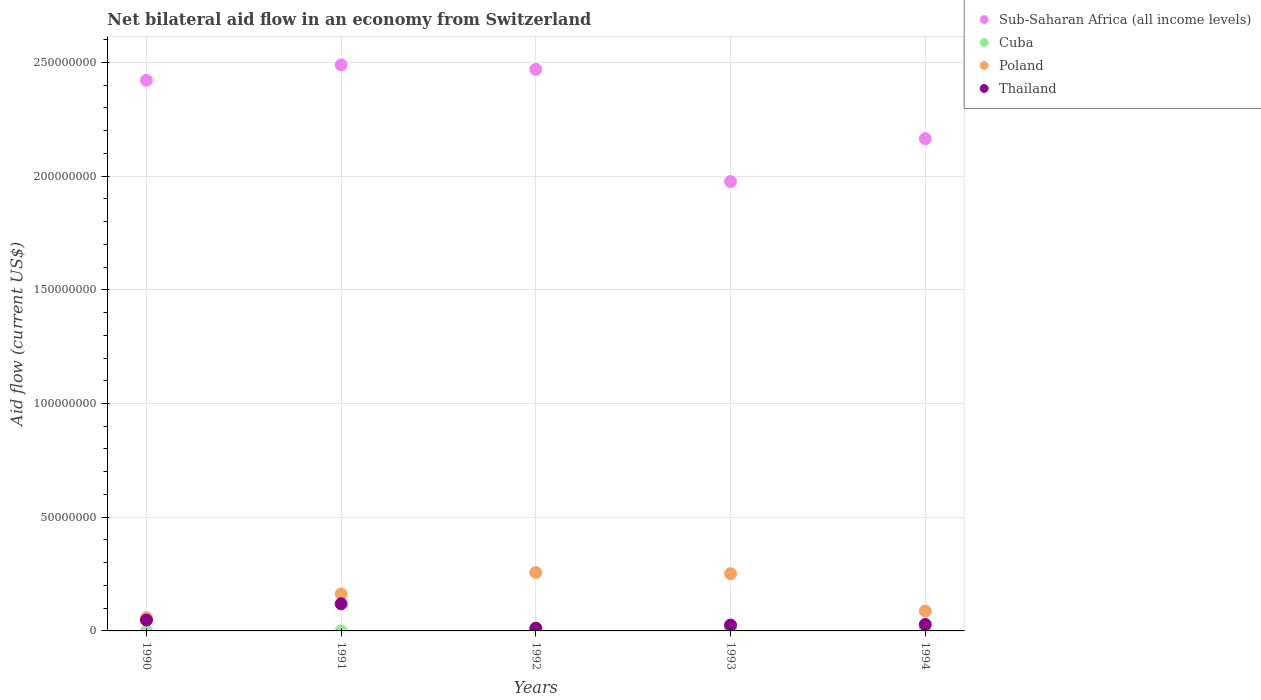How many different coloured dotlines are there?
Make the answer very short. 4. Is the number of dotlines equal to the number of legend labels?
Your response must be concise. Yes. What is the net bilateral aid flow in Thailand in 1990?
Ensure brevity in your answer.  4.78e+06. Across all years, what is the maximum net bilateral aid flow in Sub-Saharan Africa (all income levels)?
Your answer should be very brief. 2.49e+08. Across all years, what is the minimum net bilateral aid flow in Sub-Saharan Africa (all income levels)?
Ensure brevity in your answer.  1.98e+08. In which year was the net bilateral aid flow in Sub-Saharan Africa (all income levels) maximum?
Offer a very short reply. 1991. In which year was the net bilateral aid flow in Sub-Saharan Africa (all income levels) minimum?
Provide a short and direct response. 1993. What is the total net bilateral aid flow in Cuba in the graph?
Offer a very short reply. 9.30e+05. What is the difference between the net bilateral aid flow in Cuba in 1992 and that in 1993?
Keep it short and to the point. -4.50e+05. What is the difference between the net bilateral aid flow in Poland in 1991 and the net bilateral aid flow in Sub-Saharan Africa (all income levels) in 1994?
Provide a succinct answer. -2.00e+08. What is the average net bilateral aid flow in Poland per year?
Give a very brief answer. 1.63e+07. In the year 1991, what is the difference between the net bilateral aid flow in Sub-Saharan Africa (all income levels) and net bilateral aid flow in Poland?
Offer a very short reply. 2.33e+08. What is the ratio of the net bilateral aid flow in Cuba in 1991 to that in 1994?
Provide a succinct answer. 0.21. Is the difference between the net bilateral aid flow in Sub-Saharan Africa (all income levels) in 1993 and 1994 greater than the difference between the net bilateral aid flow in Poland in 1993 and 1994?
Offer a terse response. No. What is the difference between the highest and the second highest net bilateral aid flow in Thailand?
Provide a short and direct response. 7.16e+06. What is the difference between the highest and the lowest net bilateral aid flow in Poland?
Your answer should be very brief. 1.99e+07. In how many years, is the net bilateral aid flow in Poland greater than the average net bilateral aid flow in Poland taken over all years?
Give a very brief answer. 2. Is it the case that in every year, the sum of the net bilateral aid flow in Poland and net bilateral aid flow in Sub-Saharan Africa (all income levels)  is greater than the sum of net bilateral aid flow in Thailand and net bilateral aid flow in Cuba?
Offer a very short reply. Yes. What is the difference between two consecutive major ticks on the Y-axis?
Offer a terse response. 5.00e+07. Are the values on the major ticks of Y-axis written in scientific E-notation?
Provide a succinct answer. No. Does the graph contain any zero values?
Make the answer very short. No. How many legend labels are there?
Offer a terse response. 4. What is the title of the graph?
Ensure brevity in your answer.  Net bilateral aid flow in an economy from Switzerland. Does "Libya" appear as one of the legend labels in the graph?
Ensure brevity in your answer.  No. What is the Aid flow (current US$) in Sub-Saharan Africa (all income levels) in 1990?
Keep it short and to the point. 2.42e+08. What is the Aid flow (current US$) of Cuba in 1990?
Ensure brevity in your answer.  3.00e+04. What is the Aid flow (current US$) in Poland in 1990?
Offer a very short reply. 5.79e+06. What is the Aid flow (current US$) of Thailand in 1990?
Offer a very short reply. 4.78e+06. What is the Aid flow (current US$) of Sub-Saharan Africa (all income levels) in 1991?
Keep it short and to the point. 2.49e+08. What is the Aid flow (current US$) of Cuba in 1991?
Your answer should be very brief. 4.00e+04. What is the Aid flow (current US$) in Poland in 1991?
Your answer should be very brief. 1.63e+07. What is the Aid flow (current US$) of Thailand in 1991?
Give a very brief answer. 1.19e+07. What is the Aid flow (current US$) in Sub-Saharan Africa (all income levels) in 1992?
Offer a terse response. 2.47e+08. What is the Aid flow (current US$) in Poland in 1992?
Keep it short and to the point. 2.57e+07. What is the Aid flow (current US$) of Thailand in 1992?
Give a very brief answer. 1.21e+06. What is the Aid flow (current US$) of Sub-Saharan Africa (all income levels) in 1993?
Your answer should be very brief. 1.98e+08. What is the Aid flow (current US$) of Cuba in 1993?
Ensure brevity in your answer.  5.60e+05. What is the Aid flow (current US$) of Poland in 1993?
Offer a terse response. 2.52e+07. What is the Aid flow (current US$) in Thailand in 1993?
Offer a very short reply. 2.58e+06. What is the Aid flow (current US$) of Sub-Saharan Africa (all income levels) in 1994?
Provide a short and direct response. 2.16e+08. What is the Aid flow (current US$) in Cuba in 1994?
Offer a terse response. 1.90e+05. What is the Aid flow (current US$) in Poland in 1994?
Offer a very short reply. 8.76e+06. What is the Aid flow (current US$) in Thailand in 1994?
Your answer should be compact. 2.84e+06. Across all years, what is the maximum Aid flow (current US$) of Sub-Saharan Africa (all income levels)?
Give a very brief answer. 2.49e+08. Across all years, what is the maximum Aid flow (current US$) of Cuba?
Your response must be concise. 5.60e+05. Across all years, what is the maximum Aid flow (current US$) of Poland?
Your answer should be compact. 2.57e+07. Across all years, what is the maximum Aid flow (current US$) in Thailand?
Keep it short and to the point. 1.19e+07. Across all years, what is the minimum Aid flow (current US$) in Sub-Saharan Africa (all income levels)?
Your response must be concise. 1.98e+08. Across all years, what is the minimum Aid flow (current US$) in Cuba?
Provide a succinct answer. 3.00e+04. Across all years, what is the minimum Aid flow (current US$) in Poland?
Offer a very short reply. 5.79e+06. Across all years, what is the minimum Aid flow (current US$) of Thailand?
Give a very brief answer. 1.21e+06. What is the total Aid flow (current US$) of Sub-Saharan Africa (all income levels) in the graph?
Keep it short and to the point. 1.15e+09. What is the total Aid flow (current US$) in Cuba in the graph?
Keep it short and to the point. 9.30e+05. What is the total Aid flow (current US$) of Poland in the graph?
Provide a short and direct response. 8.17e+07. What is the total Aid flow (current US$) in Thailand in the graph?
Offer a terse response. 2.34e+07. What is the difference between the Aid flow (current US$) of Sub-Saharan Africa (all income levels) in 1990 and that in 1991?
Make the answer very short. -6.79e+06. What is the difference between the Aid flow (current US$) of Poland in 1990 and that in 1991?
Your answer should be very brief. -1.05e+07. What is the difference between the Aid flow (current US$) in Thailand in 1990 and that in 1991?
Your answer should be compact. -7.16e+06. What is the difference between the Aid flow (current US$) in Sub-Saharan Africa (all income levels) in 1990 and that in 1992?
Give a very brief answer. -4.80e+06. What is the difference between the Aid flow (current US$) of Cuba in 1990 and that in 1992?
Offer a very short reply. -8.00e+04. What is the difference between the Aid flow (current US$) of Poland in 1990 and that in 1992?
Offer a terse response. -1.99e+07. What is the difference between the Aid flow (current US$) of Thailand in 1990 and that in 1992?
Make the answer very short. 3.57e+06. What is the difference between the Aid flow (current US$) in Sub-Saharan Africa (all income levels) in 1990 and that in 1993?
Your response must be concise. 4.45e+07. What is the difference between the Aid flow (current US$) in Cuba in 1990 and that in 1993?
Provide a short and direct response. -5.30e+05. What is the difference between the Aid flow (current US$) in Poland in 1990 and that in 1993?
Make the answer very short. -1.94e+07. What is the difference between the Aid flow (current US$) in Thailand in 1990 and that in 1993?
Your response must be concise. 2.20e+06. What is the difference between the Aid flow (current US$) of Sub-Saharan Africa (all income levels) in 1990 and that in 1994?
Make the answer very short. 2.56e+07. What is the difference between the Aid flow (current US$) of Poland in 1990 and that in 1994?
Your answer should be very brief. -2.97e+06. What is the difference between the Aid flow (current US$) in Thailand in 1990 and that in 1994?
Give a very brief answer. 1.94e+06. What is the difference between the Aid flow (current US$) of Sub-Saharan Africa (all income levels) in 1991 and that in 1992?
Your answer should be compact. 1.99e+06. What is the difference between the Aid flow (current US$) of Cuba in 1991 and that in 1992?
Give a very brief answer. -7.00e+04. What is the difference between the Aid flow (current US$) of Poland in 1991 and that in 1992?
Ensure brevity in your answer.  -9.42e+06. What is the difference between the Aid flow (current US$) in Thailand in 1991 and that in 1992?
Keep it short and to the point. 1.07e+07. What is the difference between the Aid flow (current US$) in Sub-Saharan Africa (all income levels) in 1991 and that in 1993?
Give a very brief answer. 5.13e+07. What is the difference between the Aid flow (current US$) in Cuba in 1991 and that in 1993?
Your response must be concise. -5.20e+05. What is the difference between the Aid flow (current US$) of Poland in 1991 and that in 1993?
Make the answer very short. -8.91e+06. What is the difference between the Aid flow (current US$) of Thailand in 1991 and that in 1993?
Provide a succinct answer. 9.36e+06. What is the difference between the Aid flow (current US$) in Sub-Saharan Africa (all income levels) in 1991 and that in 1994?
Give a very brief answer. 3.24e+07. What is the difference between the Aid flow (current US$) in Poland in 1991 and that in 1994?
Give a very brief answer. 7.50e+06. What is the difference between the Aid flow (current US$) in Thailand in 1991 and that in 1994?
Ensure brevity in your answer.  9.10e+06. What is the difference between the Aid flow (current US$) in Sub-Saharan Africa (all income levels) in 1992 and that in 1993?
Your answer should be compact. 4.93e+07. What is the difference between the Aid flow (current US$) of Cuba in 1992 and that in 1993?
Offer a terse response. -4.50e+05. What is the difference between the Aid flow (current US$) in Poland in 1992 and that in 1993?
Your answer should be very brief. 5.10e+05. What is the difference between the Aid flow (current US$) in Thailand in 1992 and that in 1993?
Offer a terse response. -1.37e+06. What is the difference between the Aid flow (current US$) in Sub-Saharan Africa (all income levels) in 1992 and that in 1994?
Offer a terse response. 3.04e+07. What is the difference between the Aid flow (current US$) in Poland in 1992 and that in 1994?
Make the answer very short. 1.69e+07. What is the difference between the Aid flow (current US$) of Thailand in 1992 and that in 1994?
Offer a very short reply. -1.63e+06. What is the difference between the Aid flow (current US$) of Sub-Saharan Africa (all income levels) in 1993 and that in 1994?
Your answer should be very brief. -1.89e+07. What is the difference between the Aid flow (current US$) of Poland in 1993 and that in 1994?
Your answer should be compact. 1.64e+07. What is the difference between the Aid flow (current US$) in Sub-Saharan Africa (all income levels) in 1990 and the Aid flow (current US$) in Cuba in 1991?
Your response must be concise. 2.42e+08. What is the difference between the Aid flow (current US$) of Sub-Saharan Africa (all income levels) in 1990 and the Aid flow (current US$) of Poland in 1991?
Offer a terse response. 2.26e+08. What is the difference between the Aid flow (current US$) in Sub-Saharan Africa (all income levels) in 1990 and the Aid flow (current US$) in Thailand in 1991?
Provide a short and direct response. 2.30e+08. What is the difference between the Aid flow (current US$) of Cuba in 1990 and the Aid flow (current US$) of Poland in 1991?
Offer a terse response. -1.62e+07. What is the difference between the Aid flow (current US$) in Cuba in 1990 and the Aid flow (current US$) in Thailand in 1991?
Offer a very short reply. -1.19e+07. What is the difference between the Aid flow (current US$) of Poland in 1990 and the Aid flow (current US$) of Thailand in 1991?
Provide a succinct answer. -6.15e+06. What is the difference between the Aid flow (current US$) in Sub-Saharan Africa (all income levels) in 1990 and the Aid flow (current US$) in Cuba in 1992?
Your response must be concise. 2.42e+08. What is the difference between the Aid flow (current US$) in Sub-Saharan Africa (all income levels) in 1990 and the Aid flow (current US$) in Poland in 1992?
Your answer should be very brief. 2.16e+08. What is the difference between the Aid flow (current US$) of Sub-Saharan Africa (all income levels) in 1990 and the Aid flow (current US$) of Thailand in 1992?
Provide a short and direct response. 2.41e+08. What is the difference between the Aid flow (current US$) in Cuba in 1990 and the Aid flow (current US$) in Poland in 1992?
Make the answer very short. -2.56e+07. What is the difference between the Aid flow (current US$) in Cuba in 1990 and the Aid flow (current US$) in Thailand in 1992?
Your answer should be very brief. -1.18e+06. What is the difference between the Aid flow (current US$) in Poland in 1990 and the Aid flow (current US$) in Thailand in 1992?
Keep it short and to the point. 4.58e+06. What is the difference between the Aid flow (current US$) of Sub-Saharan Africa (all income levels) in 1990 and the Aid flow (current US$) of Cuba in 1993?
Give a very brief answer. 2.42e+08. What is the difference between the Aid flow (current US$) of Sub-Saharan Africa (all income levels) in 1990 and the Aid flow (current US$) of Poland in 1993?
Keep it short and to the point. 2.17e+08. What is the difference between the Aid flow (current US$) in Sub-Saharan Africa (all income levels) in 1990 and the Aid flow (current US$) in Thailand in 1993?
Provide a succinct answer. 2.40e+08. What is the difference between the Aid flow (current US$) in Cuba in 1990 and the Aid flow (current US$) in Poland in 1993?
Keep it short and to the point. -2.51e+07. What is the difference between the Aid flow (current US$) of Cuba in 1990 and the Aid flow (current US$) of Thailand in 1993?
Offer a terse response. -2.55e+06. What is the difference between the Aid flow (current US$) of Poland in 1990 and the Aid flow (current US$) of Thailand in 1993?
Offer a terse response. 3.21e+06. What is the difference between the Aid flow (current US$) in Sub-Saharan Africa (all income levels) in 1990 and the Aid flow (current US$) in Cuba in 1994?
Make the answer very short. 2.42e+08. What is the difference between the Aid flow (current US$) in Sub-Saharan Africa (all income levels) in 1990 and the Aid flow (current US$) in Poland in 1994?
Give a very brief answer. 2.33e+08. What is the difference between the Aid flow (current US$) of Sub-Saharan Africa (all income levels) in 1990 and the Aid flow (current US$) of Thailand in 1994?
Offer a very short reply. 2.39e+08. What is the difference between the Aid flow (current US$) in Cuba in 1990 and the Aid flow (current US$) in Poland in 1994?
Offer a terse response. -8.73e+06. What is the difference between the Aid flow (current US$) in Cuba in 1990 and the Aid flow (current US$) in Thailand in 1994?
Give a very brief answer. -2.81e+06. What is the difference between the Aid flow (current US$) in Poland in 1990 and the Aid flow (current US$) in Thailand in 1994?
Your answer should be compact. 2.95e+06. What is the difference between the Aid flow (current US$) of Sub-Saharan Africa (all income levels) in 1991 and the Aid flow (current US$) of Cuba in 1992?
Make the answer very short. 2.49e+08. What is the difference between the Aid flow (current US$) in Sub-Saharan Africa (all income levels) in 1991 and the Aid flow (current US$) in Poland in 1992?
Make the answer very short. 2.23e+08. What is the difference between the Aid flow (current US$) in Sub-Saharan Africa (all income levels) in 1991 and the Aid flow (current US$) in Thailand in 1992?
Your answer should be very brief. 2.48e+08. What is the difference between the Aid flow (current US$) in Cuba in 1991 and the Aid flow (current US$) in Poland in 1992?
Your answer should be compact. -2.56e+07. What is the difference between the Aid flow (current US$) of Cuba in 1991 and the Aid flow (current US$) of Thailand in 1992?
Provide a succinct answer. -1.17e+06. What is the difference between the Aid flow (current US$) of Poland in 1991 and the Aid flow (current US$) of Thailand in 1992?
Your answer should be compact. 1.50e+07. What is the difference between the Aid flow (current US$) in Sub-Saharan Africa (all income levels) in 1991 and the Aid flow (current US$) in Cuba in 1993?
Offer a terse response. 2.48e+08. What is the difference between the Aid flow (current US$) in Sub-Saharan Africa (all income levels) in 1991 and the Aid flow (current US$) in Poland in 1993?
Give a very brief answer. 2.24e+08. What is the difference between the Aid flow (current US$) in Sub-Saharan Africa (all income levels) in 1991 and the Aid flow (current US$) in Thailand in 1993?
Give a very brief answer. 2.46e+08. What is the difference between the Aid flow (current US$) in Cuba in 1991 and the Aid flow (current US$) in Poland in 1993?
Make the answer very short. -2.51e+07. What is the difference between the Aid flow (current US$) in Cuba in 1991 and the Aid flow (current US$) in Thailand in 1993?
Offer a terse response. -2.54e+06. What is the difference between the Aid flow (current US$) in Poland in 1991 and the Aid flow (current US$) in Thailand in 1993?
Keep it short and to the point. 1.37e+07. What is the difference between the Aid flow (current US$) of Sub-Saharan Africa (all income levels) in 1991 and the Aid flow (current US$) of Cuba in 1994?
Your answer should be compact. 2.49e+08. What is the difference between the Aid flow (current US$) of Sub-Saharan Africa (all income levels) in 1991 and the Aid flow (current US$) of Poland in 1994?
Offer a terse response. 2.40e+08. What is the difference between the Aid flow (current US$) in Sub-Saharan Africa (all income levels) in 1991 and the Aid flow (current US$) in Thailand in 1994?
Keep it short and to the point. 2.46e+08. What is the difference between the Aid flow (current US$) in Cuba in 1991 and the Aid flow (current US$) in Poland in 1994?
Provide a short and direct response. -8.72e+06. What is the difference between the Aid flow (current US$) in Cuba in 1991 and the Aid flow (current US$) in Thailand in 1994?
Offer a terse response. -2.80e+06. What is the difference between the Aid flow (current US$) of Poland in 1991 and the Aid flow (current US$) of Thailand in 1994?
Your answer should be compact. 1.34e+07. What is the difference between the Aid flow (current US$) in Sub-Saharan Africa (all income levels) in 1992 and the Aid flow (current US$) in Cuba in 1993?
Offer a very short reply. 2.46e+08. What is the difference between the Aid flow (current US$) in Sub-Saharan Africa (all income levels) in 1992 and the Aid flow (current US$) in Poland in 1993?
Make the answer very short. 2.22e+08. What is the difference between the Aid flow (current US$) in Sub-Saharan Africa (all income levels) in 1992 and the Aid flow (current US$) in Thailand in 1993?
Provide a succinct answer. 2.44e+08. What is the difference between the Aid flow (current US$) of Cuba in 1992 and the Aid flow (current US$) of Poland in 1993?
Keep it short and to the point. -2.51e+07. What is the difference between the Aid flow (current US$) in Cuba in 1992 and the Aid flow (current US$) in Thailand in 1993?
Your answer should be compact. -2.47e+06. What is the difference between the Aid flow (current US$) of Poland in 1992 and the Aid flow (current US$) of Thailand in 1993?
Provide a short and direct response. 2.31e+07. What is the difference between the Aid flow (current US$) of Sub-Saharan Africa (all income levels) in 1992 and the Aid flow (current US$) of Cuba in 1994?
Your response must be concise. 2.47e+08. What is the difference between the Aid flow (current US$) in Sub-Saharan Africa (all income levels) in 1992 and the Aid flow (current US$) in Poland in 1994?
Offer a very short reply. 2.38e+08. What is the difference between the Aid flow (current US$) in Sub-Saharan Africa (all income levels) in 1992 and the Aid flow (current US$) in Thailand in 1994?
Give a very brief answer. 2.44e+08. What is the difference between the Aid flow (current US$) of Cuba in 1992 and the Aid flow (current US$) of Poland in 1994?
Your response must be concise. -8.65e+06. What is the difference between the Aid flow (current US$) in Cuba in 1992 and the Aid flow (current US$) in Thailand in 1994?
Your answer should be very brief. -2.73e+06. What is the difference between the Aid flow (current US$) of Poland in 1992 and the Aid flow (current US$) of Thailand in 1994?
Your answer should be very brief. 2.28e+07. What is the difference between the Aid flow (current US$) of Sub-Saharan Africa (all income levels) in 1993 and the Aid flow (current US$) of Cuba in 1994?
Your response must be concise. 1.97e+08. What is the difference between the Aid flow (current US$) in Sub-Saharan Africa (all income levels) in 1993 and the Aid flow (current US$) in Poland in 1994?
Offer a very short reply. 1.89e+08. What is the difference between the Aid flow (current US$) in Sub-Saharan Africa (all income levels) in 1993 and the Aid flow (current US$) in Thailand in 1994?
Give a very brief answer. 1.95e+08. What is the difference between the Aid flow (current US$) of Cuba in 1993 and the Aid flow (current US$) of Poland in 1994?
Offer a terse response. -8.20e+06. What is the difference between the Aid flow (current US$) of Cuba in 1993 and the Aid flow (current US$) of Thailand in 1994?
Your answer should be compact. -2.28e+06. What is the difference between the Aid flow (current US$) of Poland in 1993 and the Aid flow (current US$) of Thailand in 1994?
Keep it short and to the point. 2.23e+07. What is the average Aid flow (current US$) in Sub-Saharan Africa (all income levels) per year?
Your answer should be compact. 2.30e+08. What is the average Aid flow (current US$) in Cuba per year?
Provide a short and direct response. 1.86e+05. What is the average Aid flow (current US$) of Poland per year?
Your response must be concise. 1.63e+07. What is the average Aid flow (current US$) in Thailand per year?
Make the answer very short. 4.67e+06. In the year 1990, what is the difference between the Aid flow (current US$) in Sub-Saharan Africa (all income levels) and Aid flow (current US$) in Cuba?
Provide a short and direct response. 2.42e+08. In the year 1990, what is the difference between the Aid flow (current US$) of Sub-Saharan Africa (all income levels) and Aid flow (current US$) of Poland?
Ensure brevity in your answer.  2.36e+08. In the year 1990, what is the difference between the Aid flow (current US$) in Sub-Saharan Africa (all income levels) and Aid flow (current US$) in Thailand?
Provide a short and direct response. 2.37e+08. In the year 1990, what is the difference between the Aid flow (current US$) in Cuba and Aid flow (current US$) in Poland?
Make the answer very short. -5.76e+06. In the year 1990, what is the difference between the Aid flow (current US$) of Cuba and Aid flow (current US$) of Thailand?
Provide a succinct answer. -4.75e+06. In the year 1990, what is the difference between the Aid flow (current US$) of Poland and Aid flow (current US$) of Thailand?
Your response must be concise. 1.01e+06. In the year 1991, what is the difference between the Aid flow (current US$) in Sub-Saharan Africa (all income levels) and Aid flow (current US$) in Cuba?
Your answer should be compact. 2.49e+08. In the year 1991, what is the difference between the Aid flow (current US$) in Sub-Saharan Africa (all income levels) and Aid flow (current US$) in Poland?
Your answer should be very brief. 2.33e+08. In the year 1991, what is the difference between the Aid flow (current US$) in Sub-Saharan Africa (all income levels) and Aid flow (current US$) in Thailand?
Offer a terse response. 2.37e+08. In the year 1991, what is the difference between the Aid flow (current US$) in Cuba and Aid flow (current US$) in Poland?
Offer a terse response. -1.62e+07. In the year 1991, what is the difference between the Aid flow (current US$) in Cuba and Aid flow (current US$) in Thailand?
Your answer should be very brief. -1.19e+07. In the year 1991, what is the difference between the Aid flow (current US$) of Poland and Aid flow (current US$) of Thailand?
Offer a terse response. 4.32e+06. In the year 1992, what is the difference between the Aid flow (current US$) in Sub-Saharan Africa (all income levels) and Aid flow (current US$) in Cuba?
Your answer should be very brief. 2.47e+08. In the year 1992, what is the difference between the Aid flow (current US$) of Sub-Saharan Africa (all income levels) and Aid flow (current US$) of Poland?
Your answer should be compact. 2.21e+08. In the year 1992, what is the difference between the Aid flow (current US$) of Sub-Saharan Africa (all income levels) and Aid flow (current US$) of Thailand?
Give a very brief answer. 2.46e+08. In the year 1992, what is the difference between the Aid flow (current US$) of Cuba and Aid flow (current US$) of Poland?
Provide a short and direct response. -2.56e+07. In the year 1992, what is the difference between the Aid flow (current US$) of Cuba and Aid flow (current US$) of Thailand?
Give a very brief answer. -1.10e+06. In the year 1992, what is the difference between the Aid flow (current US$) of Poland and Aid flow (current US$) of Thailand?
Offer a terse response. 2.45e+07. In the year 1993, what is the difference between the Aid flow (current US$) of Sub-Saharan Africa (all income levels) and Aid flow (current US$) of Cuba?
Give a very brief answer. 1.97e+08. In the year 1993, what is the difference between the Aid flow (current US$) in Sub-Saharan Africa (all income levels) and Aid flow (current US$) in Poland?
Make the answer very short. 1.72e+08. In the year 1993, what is the difference between the Aid flow (current US$) in Sub-Saharan Africa (all income levels) and Aid flow (current US$) in Thailand?
Ensure brevity in your answer.  1.95e+08. In the year 1993, what is the difference between the Aid flow (current US$) of Cuba and Aid flow (current US$) of Poland?
Ensure brevity in your answer.  -2.46e+07. In the year 1993, what is the difference between the Aid flow (current US$) in Cuba and Aid flow (current US$) in Thailand?
Offer a very short reply. -2.02e+06. In the year 1993, what is the difference between the Aid flow (current US$) in Poland and Aid flow (current US$) in Thailand?
Provide a succinct answer. 2.26e+07. In the year 1994, what is the difference between the Aid flow (current US$) of Sub-Saharan Africa (all income levels) and Aid flow (current US$) of Cuba?
Keep it short and to the point. 2.16e+08. In the year 1994, what is the difference between the Aid flow (current US$) of Sub-Saharan Africa (all income levels) and Aid flow (current US$) of Poland?
Offer a very short reply. 2.08e+08. In the year 1994, what is the difference between the Aid flow (current US$) in Sub-Saharan Africa (all income levels) and Aid flow (current US$) in Thailand?
Your response must be concise. 2.14e+08. In the year 1994, what is the difference between the Aid flow (current US$) of Cuba and Aid flow (current US$) of Poland?
Provide a succinct answer. -8.57e+06. In the year 1994, what is the difference between the Aid flow (current US$) in Cuba and Aid flow (current US$) in Thailand?
Keep it short and to the point. -2.65e+06. In the year 1994, what is the difference between the Aid flow (current US$) in Poland and Aid flow (current US$) in Thailand?
Keep it short and to the point. 5.92e+06. What is the ratio of the Aid flow (current US$) of Sub-Saharan Africa (all income levels) in 1990 to that in 1991?
Provide a succinct answer. 0.97. What is the ratio of the Aid flow (current US$) in Cuba in 1990 to that in 1991?
Ensure brevity in your answer.  0.75. What is the ratio of the Aid flow (current US$) of Poland in 1990 to that in 1991?
Give a very brief answer. 0.36. What is the ratio of the Aid flow (current US$) in Thailand in 1990 to that in 1991?
Provide a short and direct response. 0.4. What is the ratio of the Aid flow (current US$) in Sub-Saharan Africa (all income levels) in 1990 to that in 1992?
Make the answer very short. 0.98. What is the ratio of the Aid flow (current US$) in Cuba in 1990 to that in 1992?
Provide a short and direct response. 0.27. What is the ratio of the Aid flow (current US$) of Poland in 1990 to that in 1992?
Keep it short and to the point. 0.23. What is the ratio of the Aid flow (current US$) of Thailand in 1990 to that in 1992?
Keep it short and to the point. 3.95. What is the ratio of the Aid flow (current US$) of Sub-Saharan Africa (all income levels) in 1990 to that in 1993?
Make the answer very short. 1.23. What is the ratio of the Aid flow (current US$) in Cuba in 1990 to that in 1993?
Offer a very short reply. 0.05. What is the ratio of the Aid flow (current US$) of Poland in 1990 to that in 1993?
Your answer should be very brief. 0.23. What is the ratio of the Aid flow (current US$) in Thailand in 1990 to that in 1993?
Provide a succinct answer. 1.85. What is the ratio of the Aid flow (current US$) in Sub-Saharan Africa (all income levels) in 1990 to that in 1994?
Your answer should be compact. 1.12. What is the ratio of the Aid flow (current US$) in Cuba in 1990 to that in 1994?
Your answer should be compact. 0.16. What is the ratio of the Aid flow (current US$) of Poland in 1990 to that in 1994?
Give a very brief answer. 0.66. What is the ratio of the Aid flow (current US$) of Thailand in 1990 to that in 1994?
Offer a very short reply. 1.68. What is the ratio of the Aid flow (current US$) of Cuba in 1991 to that in 1992?
Make the answer very short. 0.36. What is the ratio of the Aid flow (current US$) in Poland in 1991 to that in 1992?
Your answer should be very brief. 0.63. What is the ratio of the Aid flow (current US$) in Thailand in 1991 to that in 1992?
Offer a terse response. 9.87. What is the ratio of the Aid flow (current US$) in Sub-Saharan Africa (all income levels) in 1991 to that in 1993?
Provide a short and direct response. 1.26. What is the ratio of the Aid flow (current US$) of Cuba in 1991 to that in 1993?
Your answer should be compact. 0.07. What is the ratio of the Aid flow (current US$) of Poland in 1991 to that in 1993?
Your answer should be very brief. 0.65. What is the ratio of the Aid flow (current US$) of Thailand in 1991 to that in 1993?
Give a very brief answer. 4.63. What is the ratio of the Aid flow (current US$) in Sub-Saharan Africa (all income levels) in 1991 to that in 1994?
Keep it short and to the point. 1.15. What is the ratio of the Aid flow (current US$) of Cuba in 1991 to that in 1994?
Provide a short and direct response. 0.21. What is the ratio of the Aid flow (current US$) in Poland in 1991 to that in 1994?
Offer a terse response. 1.86. What is the ratio of the Aid flow (current US$) of Thailand in 1991 to that in 1994?
Ensure brevity in your answer.  4.2. What is the ratio of the Aid flow (current US$) in Sub-Saharan Africa (all income levels) in 1992 to that in 1993?
Offer a terse response. 1.25. What is the ratio of the Aid flow (current US$) of Cuba in 1992 to that in 1993?
Make the answer very short. 0.2. What is the ratio of the Aid flow (current US$) in Poland in 1992 to that in 1993?
Your answer should be compact. 1.02. What is the ratio of the Aid flow (current US$) in Thailand in 1992 to that in 1993?
Give a very brief answer. 0.47. What is the ratio of the Aid flow (current US$) of Sub-Saharan Africa (all income levels) in 1992 to that in 1994?
Keep it short and to the point. 1.14. What is the ratio of the Aid flow (current US$) in Cuba in 1992 to that in 1994?
Your answer should be compact. 0.58. What is the ratio of the Aid flow (current US$) of Poland in 1992 to that in 1994?
Offer a very short reply. 2.93. What is the ratio of the Aid flow (current US$) of Thailand in 1992 to that in 1994?
Your response must be concise. 0.43. What is the ratio of the Aid flow (current US$) of Sub-Saharan Africa (all income levels) in 1993 to that in 1994?
Offer a terse response. 0.91. What is the ratio of the Aid flow (current US$) of Cuba in 1993 to that in 1994?
Your response must be concise. 2.95. What is the ratio of the Aid flow (current US$) in Poland in 1993 to that in 1994?
Make the answer very short. 2.87. What is the ratio of the Aid flow (current US$) in Thailand in 1993 to that in 1994?
Keep it short and to the point. 0.91. What is the difference between the highest and the second highest Aid flow (current US$) of Sub-Saharan Africa (all income levels)?
Offer a terse response. 1.99e+06. What is the difference between the highest and the second highest Aid flow (current US$) of Cuba?
Provide a succinct answer. 3.70e+05. What is the difference between the highest and the second highest Aid flow (current US$) of Poland?
Ensure brevity in your answer.  5.10e+05. What is the difference between the highest and the second highest Aid flow (current US$) in Thailand?
Give a very brief answer. 7.16e+06. What is the difference between the highest and the lowest Aid flow (current US$) of Sub-Saharan Africa (all income levels)?
Your answer should be compact. 5.13e+07. What is the difference between the highest and the lowest Aid flow (current US$) in Cuba?
Ensure brevity in your answer.  5.30e+05. What is the difference between the highest and the lowest Aid flow (current US$) of Poland?
Give a very brief answer. 1.99e+07. What is the difference between the highest and the lowest Aid flow (current US$) of Thailand?
Give a very brief answer. 1.07e+07. 